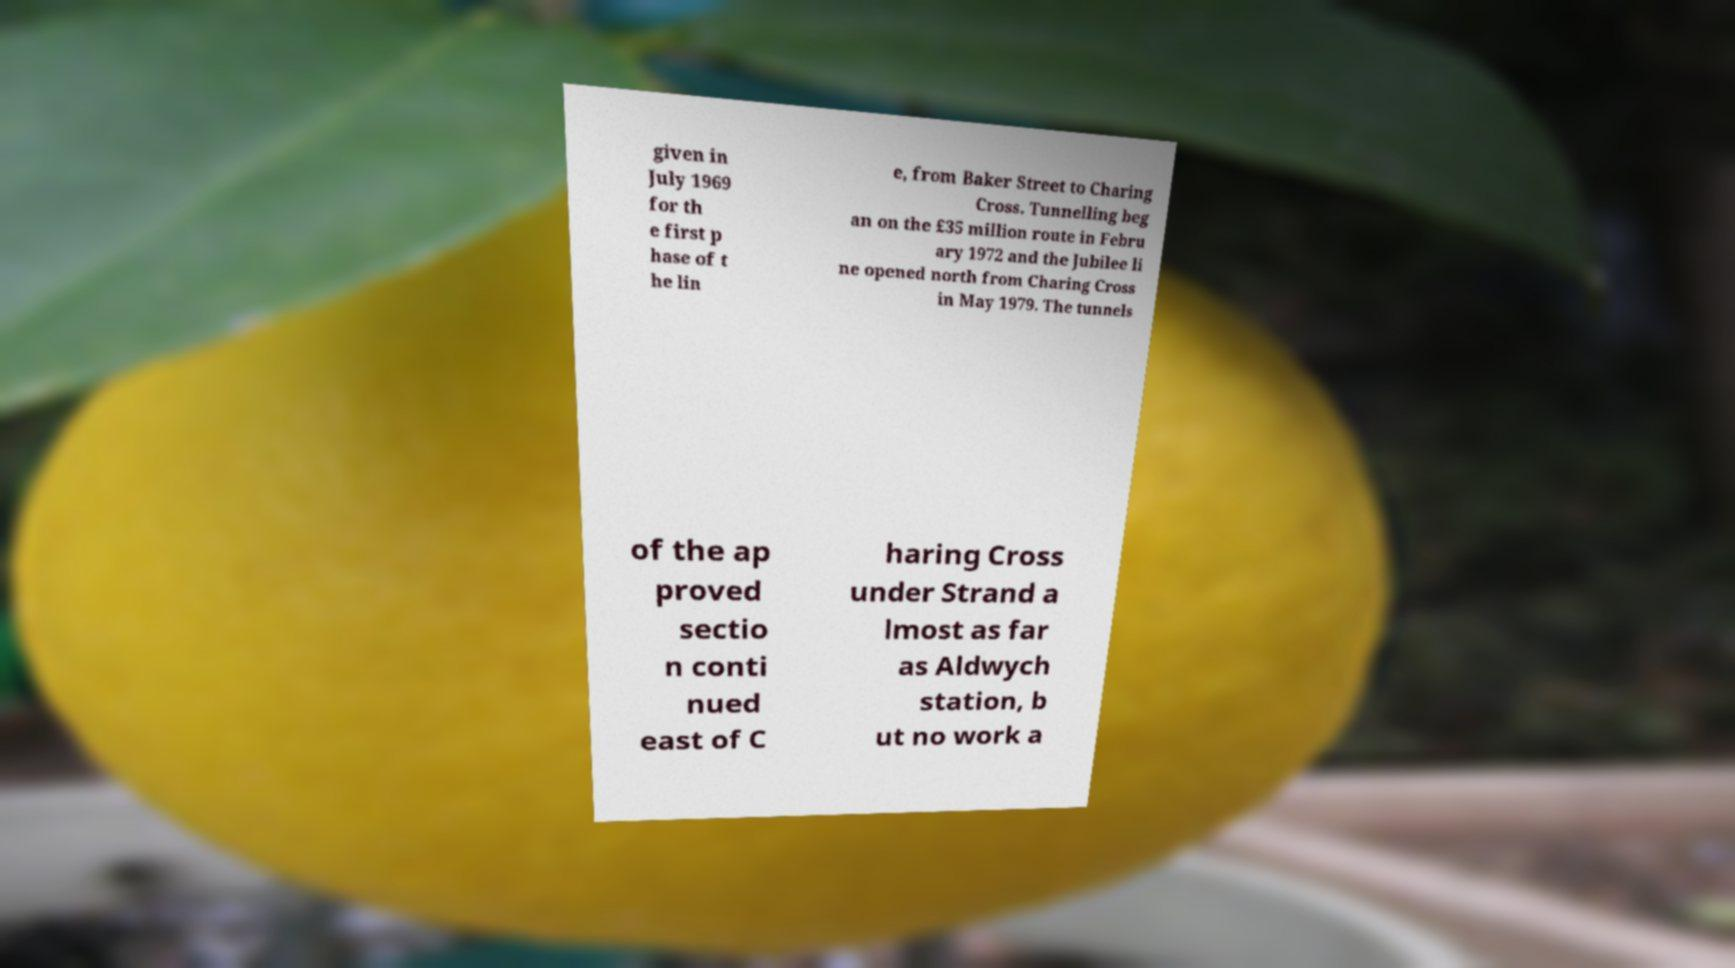Could you assist in decoding the text presented in this image and type it out clearly? given in July 1969 for th e first p hase of t he lin e, from Baker Street to Charing Cross. Tunnelling beg an on the £35 million route in Febru ary 1972 and the Jubilee li ne opened north from Charing Cross in May 1979. The tunnels of the ap proved sectio n conti nued east of C haring Cross under Strand a lmost as far as Aldwych station, b ut no work a 